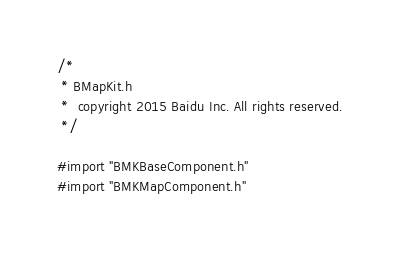Convert code to text. <code><loc_0><loc_0><loc_500><loc_500><_C_>/*
 * BMapKit.h 
 *  copyright 2015 Baidu Inc. All rights reserved.
 */

#import "BMKBaseComponent.h"
#import "BMKMapComponent.h"</code> 